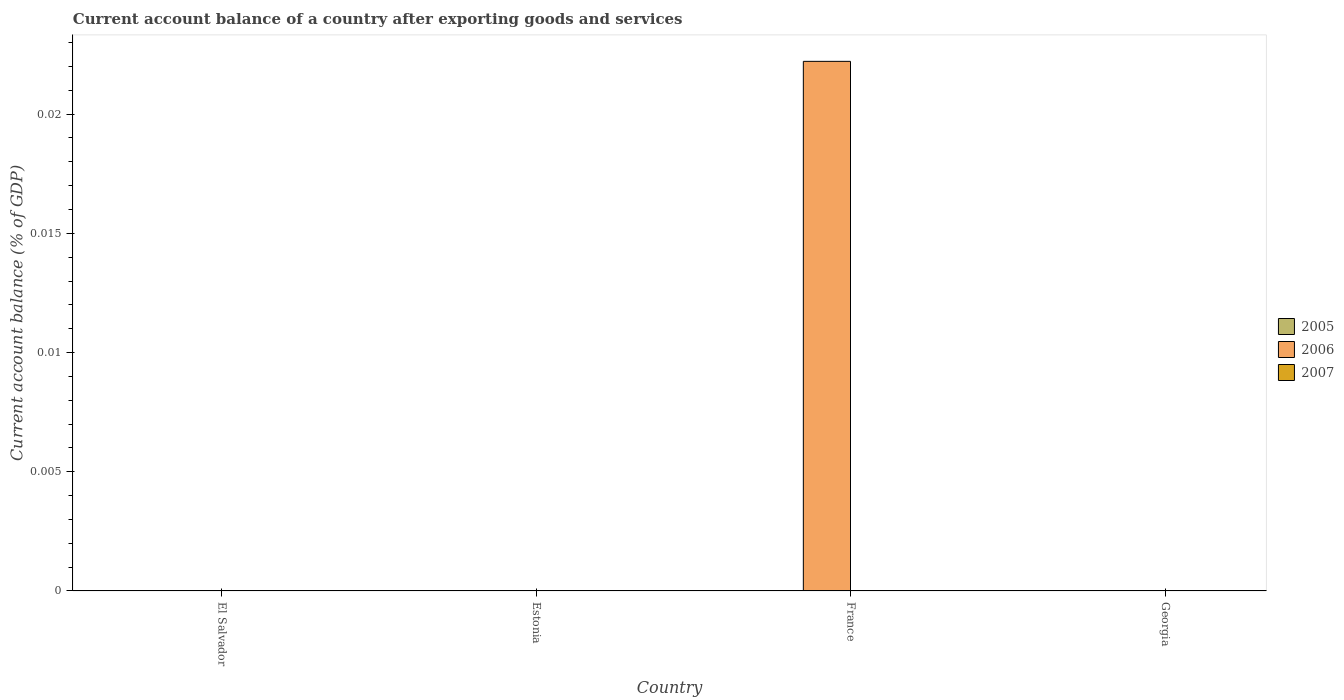How many different coloured bars are there?
Provide a short and direct response. 1. Are the number of bars per tick equal to the number of legend labels?
Your answer should be compact. No. What is the label of the 3rd group of bars from the left?
Offer a very short reply. France. In how many cases, is the number of bars for a given country not equal to the number of legend labels?
Ensure brevity in your answer.  4. Across all countries, what is the maximum account balance in 2006?
Make the answer very short. 0.02. Across all countries, what is the minimum account balance in 2005?
Your answer should be compact. 0. In which country was the account balance in 2006 maximum?
Provide a short and direct response. France. What is the total account balance in 2005 in the graph?
Offer a terse response. 0. What is the difference between the account balance in 2005 in Estonia and the account balance in 2006 in France?
Offer a terse response. -0.02. What is the average account balance in 2006 per country?
Give a very brief answer. 0.01. In how many countries, is the account balance in 2007 greater than 0.016 %?
Offer a terse response. 0. What is the difference between the highest and the lowest account balance in 2006?
Your answer should be very brief. 0.02. Is it the case that in every country, the sum of the account balance in 2005 and account balance in 2006 is greater than the account balance in 2007?
Offer a very short reply. No. How many bars are there?
Provide a short and direct response. 1. Are all the bars in the graph horizontal?
Offer a very short reply. No. How many countries are there in the graph?
Offer a very short reply. 4. What is the difference between two consecutive major ticks on the Y-axis?
Ensure brevity in your answer.  0.01. Does the graph contain grids?
Ensure brevity in your answer.  No. Where does the legend appear in the graph?
Ensure brevity in your answer.  Center right. How many legend labels are there?
Your answer should be compact. 3. What is the title of the graph?
Provide a succinct answer. Current account balance of a country after exporting goods and services. What is the label or title of the Y-axis?
Offer a terse response. Current account balance (% of GDP). What is the Current account balance (% of GDP) of 2006 in El Salvador?
Your response must be concise. 0. What is the Current account balance (% of GDP) of 2007 in El Salvador?
Your answer should be very brief. 0. What is the Current account balance (% of GDP) in 2005 in France?
Give a very brief answer. 0. What is the Current account balance (% of GDP) in 2006 in France?
Offer a very short reply. 0.02. What is the Current account balance (% of GDP) in 2005 in Georgia?
Your answer should be very brief. 0. What is the Current account balance (% of GDP) in 2007 in Georgia?
Your answer should be very brief. 0. Across all countries, what is the maximum Current account balance (% of GDP) of 2006?
Ensure brevity in your answer.  0.02. Across all countries, what is the minimum Current account balance (% of GDP) in 2006?
Provide a succinct answer. 0. What is the total Current account balance (% of GDP) of 2006 in the graph?
Your answer should be very brief. 0.02. What is the total Current account balance (% of GDP) of 2007 in the graph?
Provide a succinct answer. 0. What is the average Current account balance (% of GDP) of 2005 per country?
Your answer should be compact. 0. What is the average Current account balance (% of GDP) in 2006 per country?
Offer a very short reply. 0.01. What is the average Current account balance (% of GDP) in 2007 per country?
Ensure brevity in your answer.  0. What is the difference between the highest and the lowest Current account balance (% of GDP) in 2006?
Offer a very short reply. 0.02. 